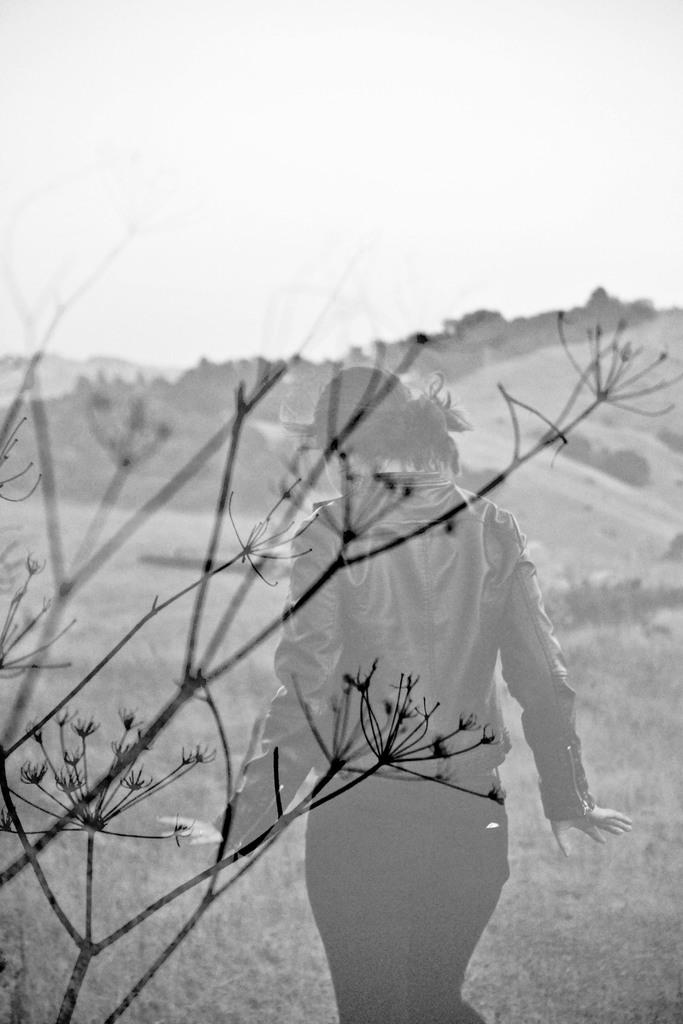What is located in the foreground of the image? There is a plant stem in the foreground of the image. Who is present in the image? There is a lady in the image. What can be seen in the background of the image? There are mountains in the background of the image. What type of vegetation is at the bottom of the image? There is grass at the bottom of the image. How many hens are visible in the image? There are no hens present in the image. What is the best way to reach the top of the mountains in the image? The image does not provide information on how to reach the top of the mountains, as it is a static representation. 